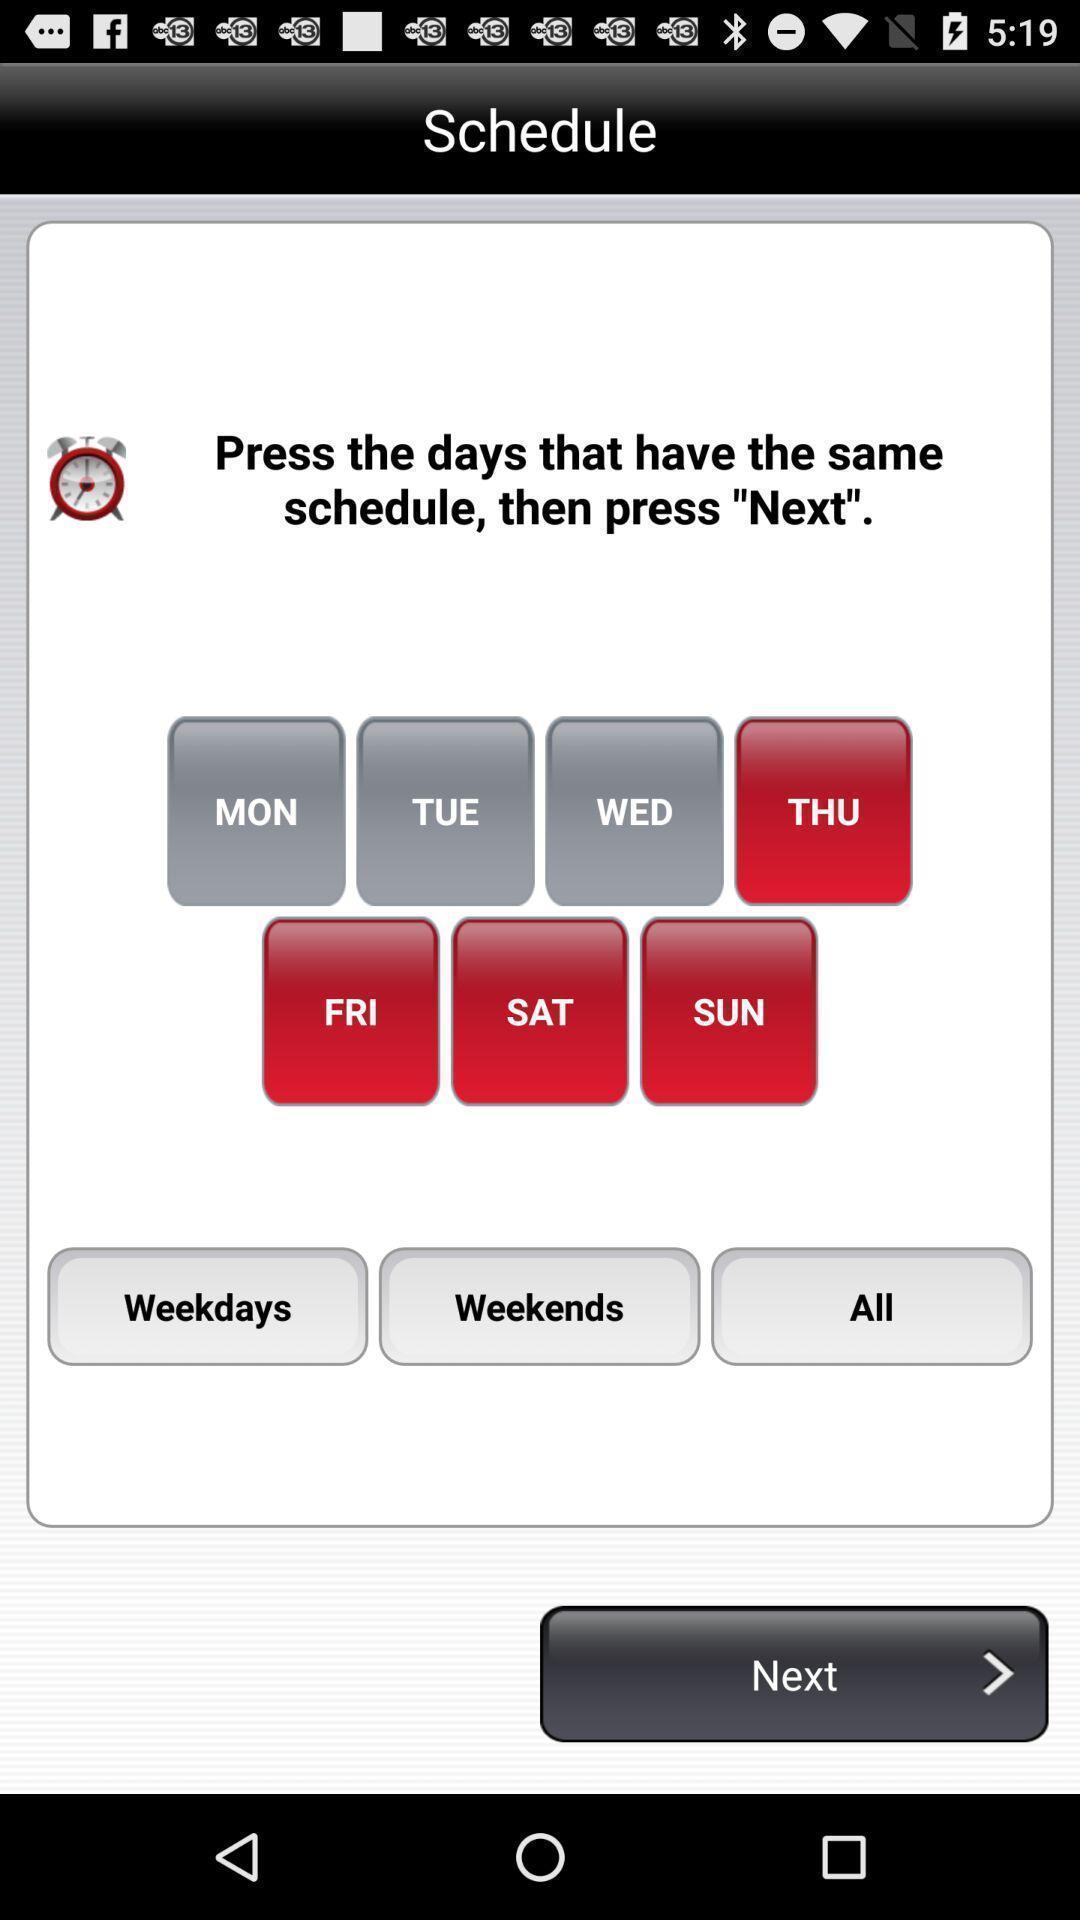What can you discern from this picture? Screen shows to schedule next days. 